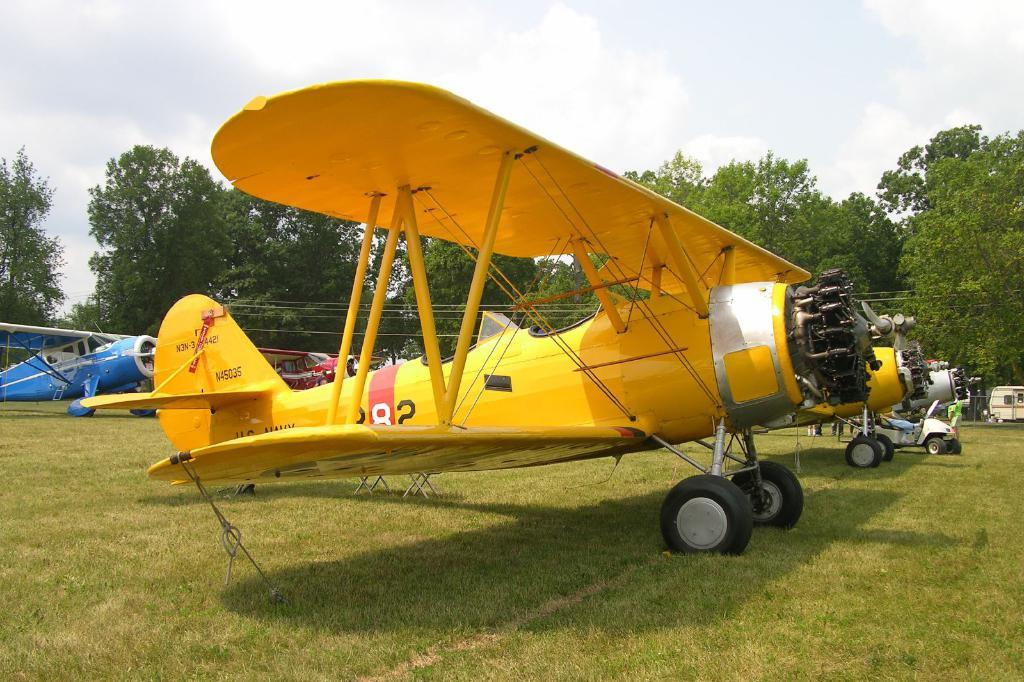<image>
Offer a succinct explanation of the picture presented. A yellow plane with a red stripe that has the number 282 on the side of it. 